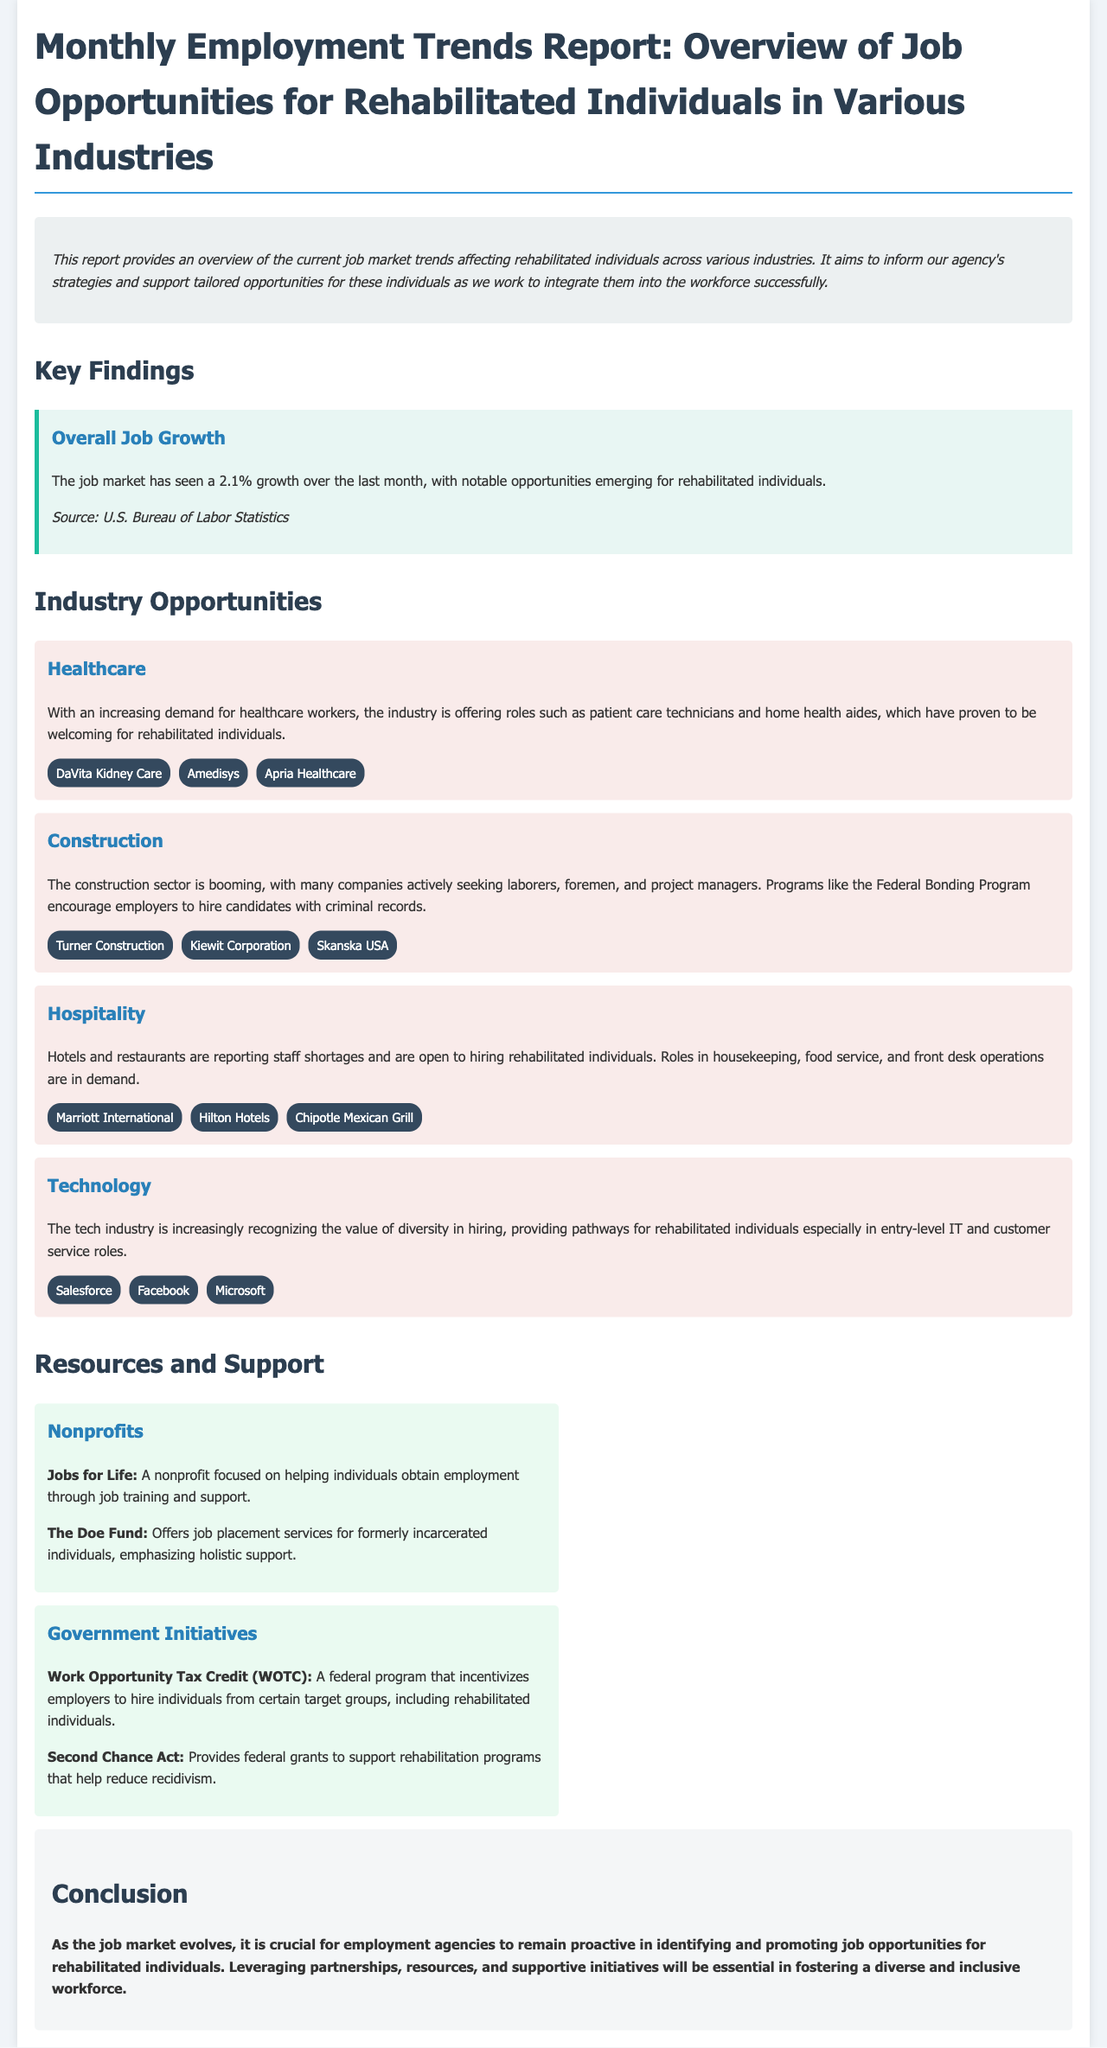What is the overall job growth percentage for the last month? The document states that the job market has seen a 2.1% growth over the last month.
Answer: 2.1% Which industry has roles such as patient care technicians? The healthcare industry is offering roles such as patient care technicians for rehabilitated individuals.
Answer: Healthcare Name one company mentioned in the construction industry. The document lists several companies in the construction sector, including Turner Construction.
Answer: Turner Construction What role in hospitality is in demand according to the report? The report indicates that housekeeping roles in the hospitality industry are in demand.
Answer: Housekeeping Which nonprofit focuses on helping individuals obtain employment? The document mentions 'Jobs for Life' as a nonprofit that helps individuals obtain employment.
Answer: Jobs for Life What program incentivizes employers to hire rehabilitated individuals? The Work Opportunity Tax Credit is mentioned as a program that incentivizes employers to hire rehabilitated individuals.
Answer: Work Opportunity Tax Credit Which industry recognizes the value of diversity in hiring? The tech industry is increasingly recognizing the value of diversity in hiring.
Answer: Technology What is a goal of the Second Chance Act mentioned in the report? The Second Chance Act provides federal grants to support rehabilitation programs and reduce recidivism.
Answer: Reduce recidivism What is the main conclusion of the report? The report concludes that it is crucial for employment agencies to remain proactive in identifying job opportunities for rehabilitated individuals.
Answer: Remain proactive 